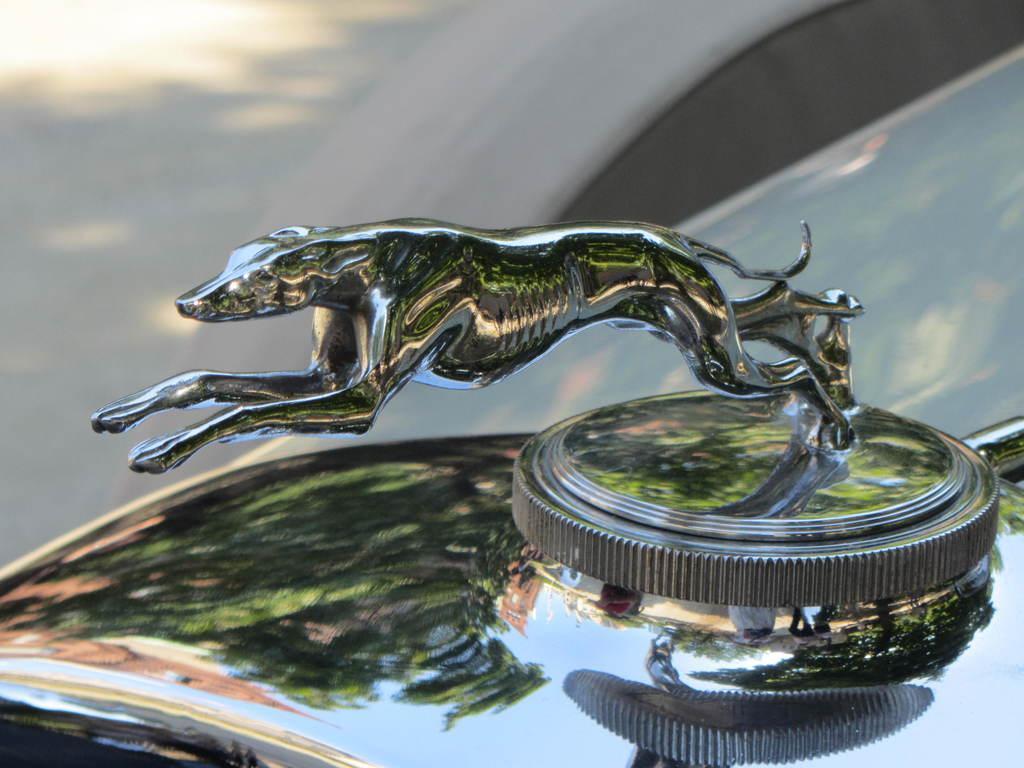Please provide a concise description of this image. In this picture we can observe a symbol of an animal on the car which is in black color. In the background it is completely blur. 